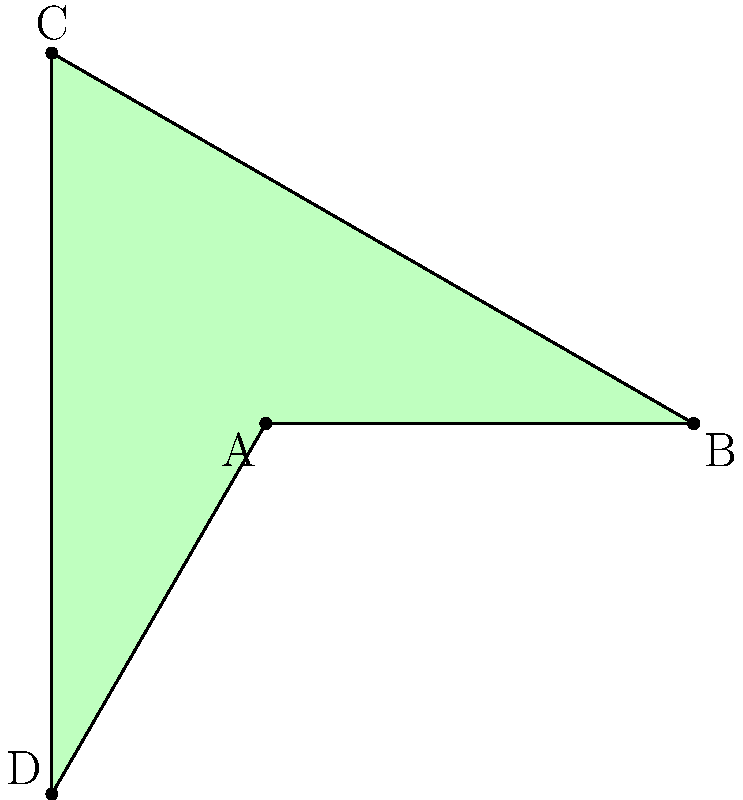As a cosmetics CEO focused on traditional packaging, consider a square-based lipstick tube represented by the green square ABCD. If we apply rotational symmetry to this configuration, how many unique orientations can be achieved before the tube returns to its original position? To determine the number of unique orientations, we need to analyze the rotational symmetry of the square:

1. A square has 4-fold rotational symmetry, meaning it can be rotated by 90°, 180°, 270°, and 360° (back to the original position).

2. Let's consider each rotation:
   - 0° (original position): ABCD
   - 90° clockwise: DABC
   - 180° clockwise: CDAB
   - 270° clockwise: BCDA
   - 360° clockwise: ABCD (back to the original position)

3. We can see that there are 4 unique orientations (including the original position) before the square returns to its initial state.

4. In group theory terms, this is represented by the cyclic group $C_4$, which has order 4.

Therefore, the square-based lipstick tube configuration has 4 unique orientations under rotational symmetry.
Answer: 4 